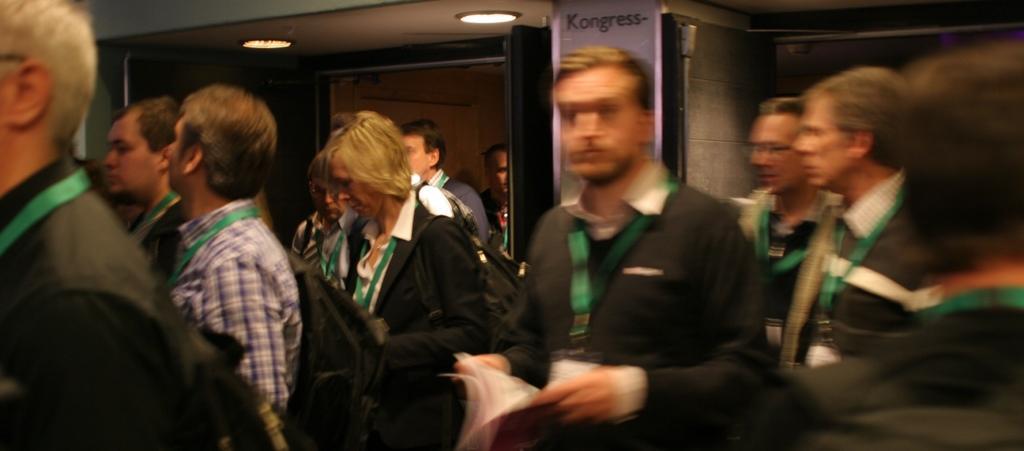Please provide a concise description of this image. In this image I can see group of people and at the top I can see a light and the door and the wall 